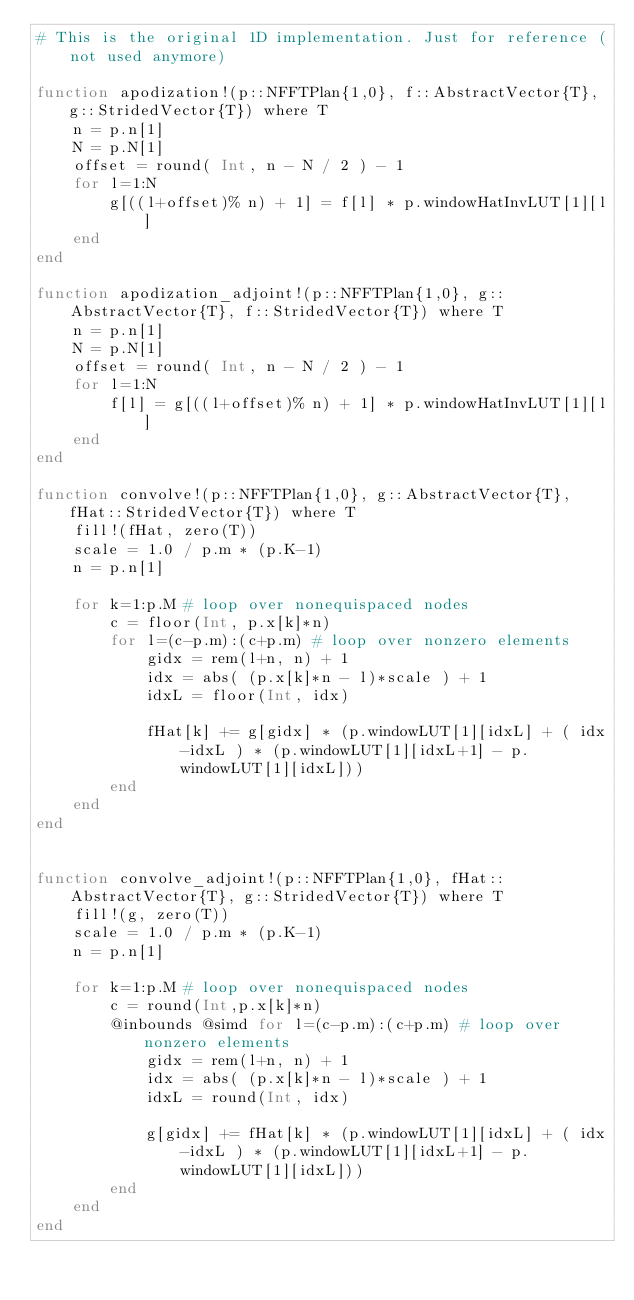Convert code to text. <code><loc_0><loc_0><loc_500><loc_500><_Julia_># This is the original 1D implementation. Just for reference (not used anymore)

function apodization!(p::NFFTPlan{1,0}, f::AbstractVector{T}, g::StridedVector{T}) where T
    n = p.n[1]
    N = p.N[1]
    offset = round( Int, n - N / 2 ) - 1
    for l=1:N
        g[((l+offset)% n) + 1] = f[l] * p.windowHatInvLUT[1][l]
    end
end

function apodization_adjoint!(p::NFFTPlan{1,0}, g::AbstractVector{T}, f::StridedVector{T}) where T
    n = p.n[1]
    N = p.N[1]
    offset = round( Int, n - N / 2 ) - 1
    for l=1:N
        f[l] = g[((l+offset)% n) + 1] * p.windowHatInvLUT[1][l]
    end
end

function convolve!(p::NFFTPlan{1,0}, g::AbstractVector{T}, fHat::StridedVector{T}) where T
    fill!(fHat, zero(T))
    scale = 1.0 / p.m * (p.K-1)
    n = p.n[1]

    for k=1:p.M # loop over nonequispaced nodes
        c = floor(Int, p.x[k]*n)
        for l=(c-p.m):(c+p.m) # loop over nonzero elements
            gidx = rem(l+n, n) + 1
            idx = abs( (p.x[k]*n - l)*scale ) + 1
            idxL = floor(Int, idx)

            fHat[k] += g[gidx] * (p.windowLUT[1][idxL] + ( idx-idxL ) * (p.windowLUT[1][idxL+1] - p.windowLUT[1][idxL]))
        end
    end
end


function convolve_adjoint!(p::NFFTPlan{1,0}, fHat::AbstractVector{T}, g::StridedVector{T}) where T
    fill!(g, zero(T))
    scale = 1.0 / p.m * (p.K-1)
    n = p.n[1]

    for k=1:p.M # loop over nonequispaced nodes
        c = round(Int,p.x[k]*n)
        @inbounds @simd for l=(c-p.m):(c+p.m) # loop over nonzero elements
            gidx = rem(l+n, n) + 1
            idx = abs( (p.x[k]*n - l)*scale ) + 1
            idxL = round(Int, idx)

            g[gidx] += fHat[k] * (p.windowLUT[1][idxL] + ( idx-idxL ) * (p.windowLUT[1][idxL+1] - p.windowLUT[1][idxL]))
        end
    end
end
</code> 